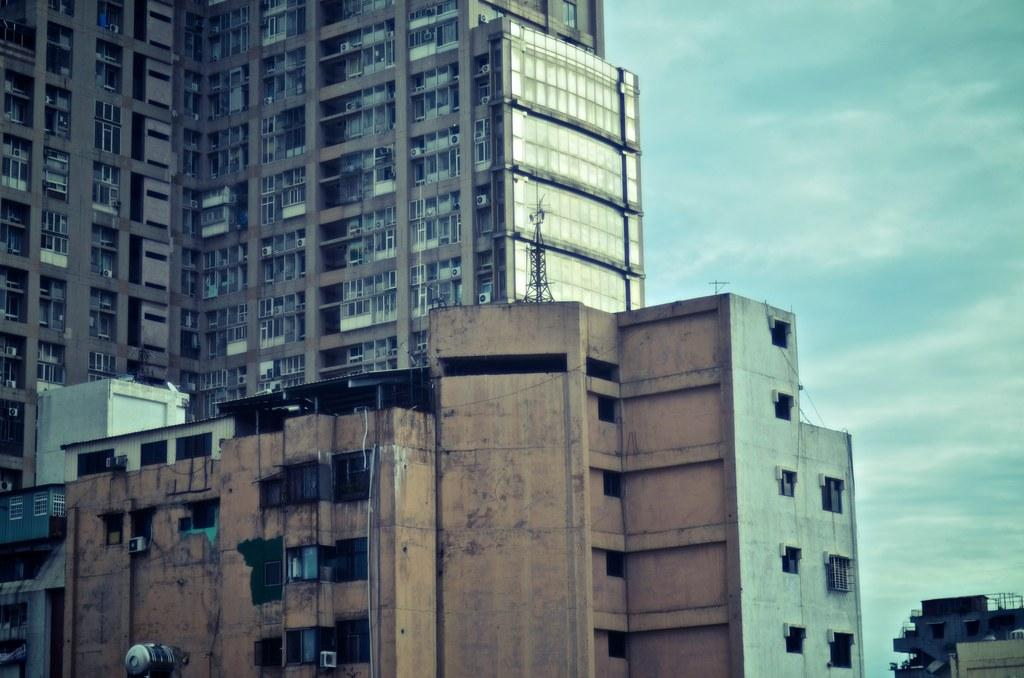What is the main subject in the center of the image? There are buildings in the center of the image. What can be seen in the background of the image? The sky is visible in the background of the image. How are the boats distributed in the image? There are no boats present in the image. 